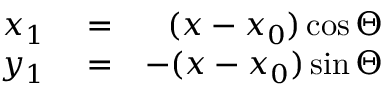Convert formula to latex. <formula><loc_0><loc_0><loc_500><loc_500>\begin{array} { r l r } { x _ { 1 } } & = } & { ( x - x _ { 0 } ) \cos \Theta } \\ { y _ { 1 } } & = } & { - ( x - x _ { 0 } ) \sin \Theta } \end{array}</formula> 